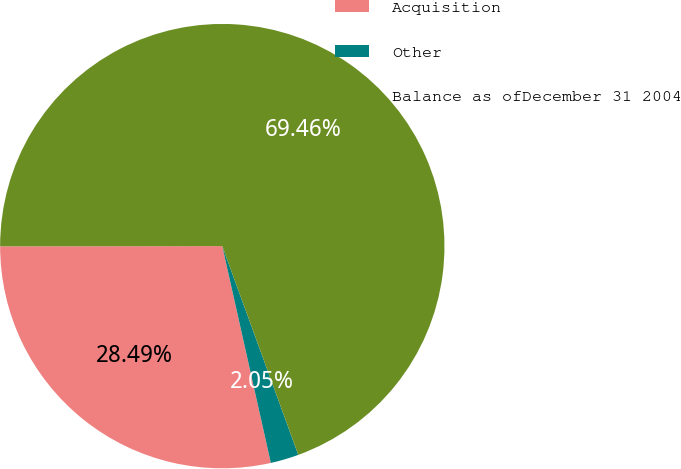Convert chart. <chart><loc_0><loc_0><loc_500><loc_500><pie_chart><fcel>Acquisition<fcel>Other<fcel>Balance as ofDecember 31 2004<nl><fcel>28.49%<fcel>2.05%<fcel>69.46%<nl></chart> 